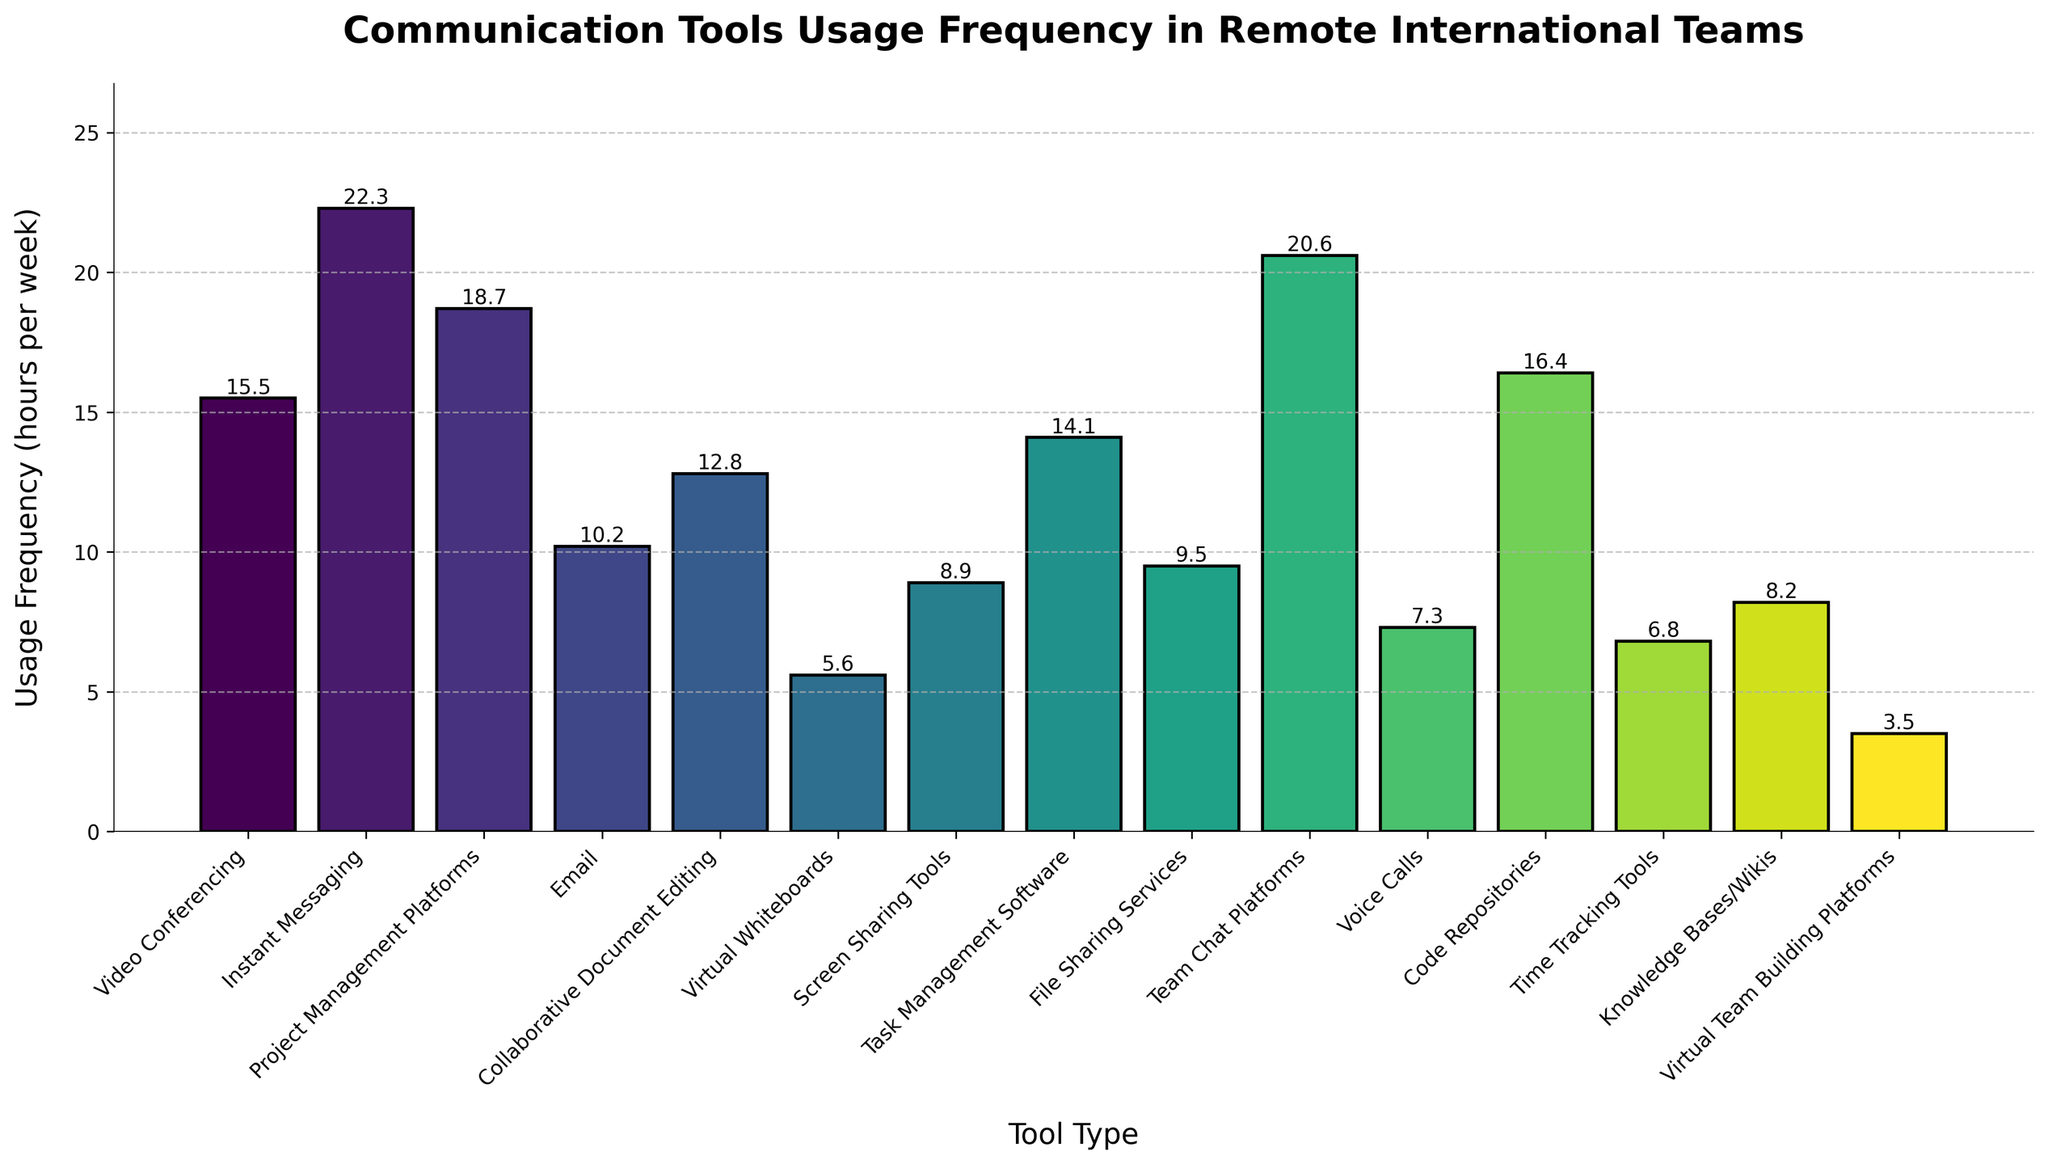Which tool has the highest usage frequency? From the bar chart, the tool with the highest bar represents the highest usage frequency. Instant Messaging has the tallest bar.
Answer: Instant Messaging What's the difference in usage frequency between the tool with the highest usage and the tool with the lowest usage? The highest usage frequency is 22.3 hours per week (Instant Messaging), and the lowest is 3.5 hours per week (Virtual Team Building Platforms). The difference is 22.3 - 3.5.
Answer: 18.8 How much is the combined usage frequency of Video Conferencing, Project Management Platforms, and Collaborative Document Editing? Add the usage frequencies of Video Conferencing (15.5), Project Management Platforms (18.7), and Collaborative Document Editing (12.8). The sum is 15.5 + 18.7 + 12.8.
Answer: 47.0 Which tool type has a usage frequency closest to 10 hours per week? From the chart, Email has a usage frequency of 10.2 hours per week, which is closest to 10 hours.
Answer: Email Is the usage frequency of Code Repositories greater than that of Team Chat Platforms? Compare the heights of the bars for Code Repositories (16.4) and Team Chat Platforms (20.6). 16.4 is less than 20.6.
Answer: No What is the average usage frequency of Virtual Whiteboards, Screen Sharing Tools, and Voice Calls? Calculate the average by summing the frequencies of Virtual Whiteboards (5.6), Screen Sharing Tools (8.9), and Voice Calls (7.3), then divide by 3. (5.6 + 8.9 + 7.3) / 3
Answer: 7.27 Which tool type has a usage frequency indicated by the most visually distinct color in the bar chart? Virtual Team Building Platforms has the most visually distinct color as it has the darkest shade compared to others.
Answer: Virtual Team Building Platforms Which tools have a usage frequency below 10 hours per week? From the chart, tools with frequencies below 10 hours per week are Virtual Whiteboards (5.6), Screen Sharing Tools (8.9), Voice Calls (7.3), Time Tracking Tools (6.8), Knowledge Bases/Wikis (8.2), and Virtual Team Building Platforms (3.5).
Answer: Virtual Whiteboards, Screen Sharing Tools, Voice Calls, Time Tracking Tools, Knowledge Bases/Wikis, Virtual Team Building Platforms What's the combined usage frequency of the three tools with the lowest usage? Virtual Team Building Platforms (3.5), Virtual Whiteboards (5.6), and Time Tracking Tools (6.8) are the three tools with the lowest usage. Their combined frequency is 3.5 + 5.6 + 6.8.
Answer: 15.9 